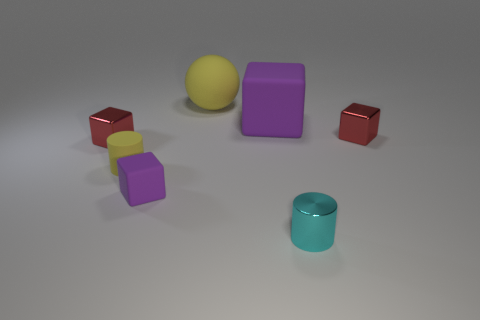Is the color of the tiny metallic cylinder the same as the small metallic cube on the left side of the tiny yellow object?
Give a very brief answer. No. There is a big rubber block; are there any small cyan metal cylinders behind it?
Ensure brevity in your answer.  No. Does the large yellow ball have the same material as the cyan cylinder?
Ensure brevity in your answer.  No. There is another cylinder that is the same size as the yellow cylinder; what is it made of?
Your answer should be very brief. Metal. What number of things are matte things that are on the left side of the large yellow matte object or purple rubber blocks?
Offer a very short reply. 3. Is the number of tiny red shiny cubes that are on the right side of the tiny yellow rubber cylinder the same as the number of cylinders?
Your answer should be compact. No. Is the sphere the same color as the big block?
Provide a short and direct response. No. What is the color of the tiny thing that is both behind the small yellow thing and on the right side of the sphere?
Your answer should be compact. Red. How many cylinders are either rubber things or tiny metal things?
Your answer should be very brief. 2. Are there fewer big balls that are right of the large purple block than small purple things?
Provide a succinct answer. Yes. 